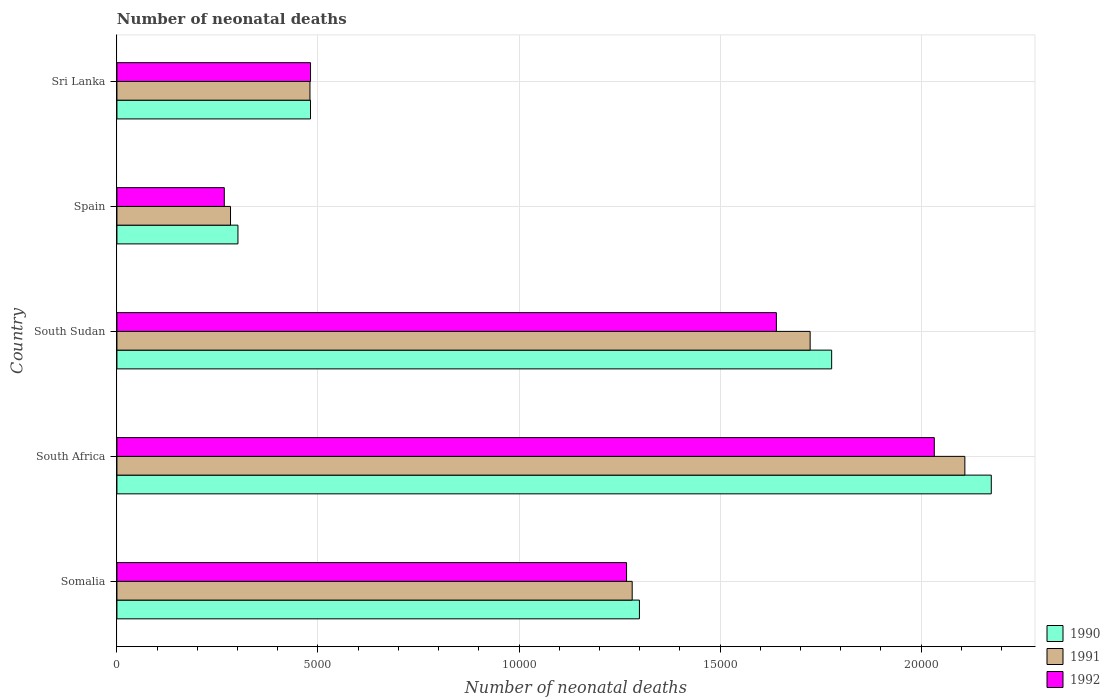How many different coloured bars are there?
Your answer should be very brief. 3. Are the number of bars per tick equal to the number of legend labels?
Provide a succinct answer. Yes. What is the label of the 2nd group of bars from the top?
Offer a terse response. Spain. What is the number of neonatal deaths in in 1991 in South Africa?
Ensure brevity in your answer.  2.11e+04. Across all countries, what is the maximum number of neonatal deaths in in 1992?
Provide a succinct answer. 2.03e+04. Across all countries, what is the minimum number of neonatal deaths in in 1991?
Ensure brevity in your answer.  2825. In which country was the number of neonatal deaths in in 1992 maximum?
Offer a very short reply. South Africa. What is the total number of neonatal deaths in in 1990 in the graph?
Your response must be concise. 6.03e+04. What is the difference between the number of neonatal deaths in in 1991 in Spain and that in Sri Lanka?
Your answer should be compact. -1976. What is the difference between the number of neonatal deaths in in 1990 in Sri Lanka and the number of neonatal deaths in in 1991 in South Sudan?
Ensure brevity in your answer.  -1.24e+04. What is the average number of neonatal deaths in in 1991 per country?
Keep it short and to the point. 1.18e+04. What is the difference between the number of neonatal deaths in in 1990 and number of neonatal deaths in in 1992 in Somalia?
Provide a short and direct response. 320. In how many countries, is the number of neonatal deaths in in 1991 greater than 4000 ?
Offer a very short reply. 4. What is the ratio of the number of neonatal deaths in in 1990 in Somalia to that in South Africa?
Keep it short and to the point. 0.6. Is the difference between the number of neonatal deaths in in 1990 in Spain and Sri Lanka greater than the difference between the number of neonatal deaths in in 1992 in Spain and Sri Lanka?
Keep it short and to the point. Yes. What is the difference between the highest and the second highest number of neonatal deaths in in 1992?
Keep it short and to the point. 3928. What is the difference between the highest and the lowest number of neonatal deaths in in 1991?
Offer a very short reply. 1.83e+04. In how many countries, is the number of neonatal deaths in in 1991 greater than the average number of neonatal deaths in in 1991 taken over all countries?
Provide a short and direct response. 3. Is the sum of the number of neonatal deaths in in 1992 in South Africa and Spain greater than the maximum number of neonatal deaths in in 1991 across all countries?
Your answer should be compact. Yes. What does the 2nd bar from the top in Sri Lanka represents?
Provide a short and direct response. 1991. Is it the case that in every country, the sum of the number of neonatal deaths in in 1992 and number of neonatal deaths in in 1990 is greater than the number of neonatal deaths in in 1991?
Your answer should be very brief. Yes. How many bars are there?
Offer a very short reply. 15. How many countries are there in the graph?
Ensure brevity in your answer.  5. Are the values on the major ticks of X-axis written in scientific E-notation?
Your answer should be very brief. No. Does the graph contain any zero values?
Your response must be concise. No. Does the graph contain grids?
Provide a short and direct response. Yes. Where does the legend appear in the graph?
Your answer should be compact. Bottom right. How many legend labels are there?
Make the answer very short. 3. What is the title of the graph?
Offer a terse response. Number of neonatal deaths. What is the label or title of the X-axis?
Your answer should be compact. Number of neonatal deaths. What is the Number of neonatal deaths of 1990 in Somalia?
Keep it short and to the point. 1.30e+04. What is the Number of neonatal deaths in 1991 in Somalia?
Offer a terse response. 1.28e+04. What is the Number of neonatal deaths in 1992 in Somalia?
Provide a short and direct response. 1.27e+04. What is the Number of neonatal deaths of 1990 in South Africa?
Your answer should be very brief. 2.17e+04. What is the Number of neonatal deaths of 1991 in South Africa?
Provide a short and direct response. 2.11e+04. What is the Number of neonatal deaths of 1992 in South Africa?
Offer a very short reply. 2.03e+04. What is the Number of neonatal deaths in 1990 in South Sudan?
Give a very brief answer. 1.78e+04. What is the Number of neonatal deaths in 1991 in South Sudan?
Your answer should be compact. 1.72e+04. What is the Number of neonatal deaths in 1992 in South Sudan?
Ensure brevity in your answer.  1.64e+04. What is the Number of neonatal deaths of 1990 in Spain?
Your answer should be very brief. 3010. What is the Number of neonatal deaths in 1991 in Spain?
Make the answer very short. 2825. What is the Number of neonatal deaths in 1992 in Spain?
Provide a short and direct response. 2670. What is the Number of neonatal deaths of 1990 in Sri Lanka?
Give a very brief answer. 4814. What is the Number of neonatal deaths of 1991 in Sri Lanka?
Ensure brevity in your answer.  4801. What is the Number of neonatal deaths in 1992 in Sri Lanka?
Provide a succinct answer. 4815. Across all countries, what is the maximum Number of neonatal deaths in 1990?
Keep it short and to the point. 2.17e+04. Across all countries, what is the maximum Number of neonatal deaths of 1991?
Provide a short and direct response. 2.11e+04. Across all countries, what is the maximum Number of neonatal deaths of 1992?
Ensure brevity in your answer.  2.03e+04. Across all countries, what is the minimum Number of neonatal deaths of 1990?
Offer a terse response. 3010. Across all countries, what is the minimum Number of neonatal deaths of 1991?
Your answer should be compact. 2825. Across all countries, what is the minimum Number of neonatal deaths in 1992?
Offer a very short reply. 2670. What is the total Number of neonatal deaths of 1990 in the graph?
Keep it short and to the point. 6.03e+04. What is the total Number of neonatal deaths in 1991 in the graph?
Keep it short and to the point. 5.88e+04. What is the total Number of neonatal deaths of 1992 in the graph?
Provide a succinct answer. 5.69e+04. What is the difference between the Number of neonatal deaths of 1990 in Somalia and that in South Africa?
Offer a very short reply. -8751. What is the difference between the Number of neonatal deaths of 1991 in Somalia and that in South Africa?
Your response must be concise. -8274. What is the difference between the Number of neonatal deaths of 1992 in Somalia and that in South Africa?
Ensure brevity in your answer.  -7654. What is the difference between the Number of neonatal deaths of 1990 in Somalia and that in South Sudan?
Keep it short and to the point. -4781. What is the difference between the Number of neonatal deaths of 1991 in Somalia and that in South Sudan?
Ensure brevity in your answer.  -4426. What is the difference between the Number of neonatal deaths of 1992 in Somalia and that in South Sudan?
Offer a very short reply. -3726. What is the difference between the Number of neonatal deaths of 1990 in Somalia and that in Spain?
Provide a succinct answer. 9985. What is the difference between the Number of neonatal deaths in 1991 in Somalia and that in Spain?
Offer a terse response. 9990. What is the difference between the Number of neonatal deaths of 1992 in Somalia and that in Spain?
Offer a very short reply. 1.00e+04. What is the difference between the Number of neonatal deaths in 1990 in Somalia and that in Sri Lanka?
Offer a very short reply. 8181. What is the difference between the Number of neonatal deaths in 1991 in Somalia and that in Sri Lanka?
Keep it short and to the point. 8014. What is the difference between the Number of neonatal deaths in 1992 in Somalia and that in Sri Lanka?
Give a very brief answer. 7860. What is the difference between the Number of neonatal deaths of 1990 in South Africa and that in South Sudan?
Your answer should be very brief. 3970. What is the difference between the Number of neonatal deaths in 1991 in South Africa and that in South Sudan?
Provide a short and direct response. 3848. What is the difference between the Number of neonatal deaths of 1992 in South Africa and that in South Sudan?
Provide a short and direct response. 3928. What is the difference between the Number of neonatal deaths in 1990 in South Africa and that in Spain?
Offer a terse response. 1.87e+04. What is the difference between the Number of neonatal deaths of 1991 in South Africa and that in Spain?
Your answer should be very brief. 1.83e+04. What is the difference between the Number of neonatal deaths of 1992 in South Africa and that in Spain?
Offer a very short reply. 1.77e+04. What is the difference between the Number of neonatal deaths of 1990 in South Africa and that in Sri Lanka?
Provide a short and direct response. 1.69e+04. What is the difference between the Number of neonatal deaths in 1991 in South Africa and that in Sri Lanka?
Your answer should be very brief. 1.63e+04. What is the difference between the Number of neonatal deaths in 1992 in South Africa and that in Sri Lanka?
Provide a succinct answer. 1.55e+04. What is the difference between the Number of neonatal deaths of 1990 in South Sudan and that in Spain?
Provide a short and direct response. 1.48e+04. What is the difference between the Number of neonatal deaths in 1991 in South Sudan and that in Spain?
Offer a terse response. 1.44e+04. What is the difference between the Number of neonatal deaths in 1992 in South Sudan and that in Spain?
Offer a terse response. 1.37e+04. What is the difference between the Number of neonatal deaths of 1990 in South Sudan and that in Sri Lanka?
Your response must be concise. 1.30e+04. What is the difference between the Number of neonatal deaths in 1991 in South Sudan and that in Sri Lanka?
Your answer should be very brief. 1.24e+04. What is the difference between the Number of neonatal deaths in 1992 in South Sudan and that in Sri Lanka?
Keep it short and to the point. 1.16e+04. What is the difference between the Number of neonatal deaths of 1990 in Spain and that in Sri Lanka?
Keep it short and to the point. -1804. What is the difference between the Number of neonatal deaths of 1991 in Spain and that in Sri Lanka?
Ensure brevity in your answer.  -1976. What is the difference between the Number of neonatal deaths of 1992 in Spain and that in Sri Lanka?
Offer a very short reply. -2145. What is the difference between the Number of neonatal deaths of 1990 in Somalia and the Number of neonatal deaths of 1991 in South Africa?
Your response must be concise. -8094. What is the difference between the Number of neonatal deaths of 1990 in Somalia and the Number of neonatal deaths of 1992 in South Africa?
Give a very brief answer. -7334. What is the difference between the Number of neonatal deaths of 1991 in Somalia and the Number of neonatal deaths of 1992 in South Africa?
Your answer should be compact. -7514. What is the difference between the Number of neonatal deaths of 1990 in Somalia and the Number of neonatal deaths of 1991 in South Sudan?
Your answer should be compact. -4246. What is the difference between the Number of neonatal deaths in 1990 in Somalia and the Number of neonatal deaths in 1992 in South Sudan?
Offer a very short reply. -3406. What is the difference between the Number of neonatal deaths in 1991 in Somalia and the Number of neonatal deaths in 1992 in South Sudan?
Provide a short and direct response. -3586. What is the difference between the Number of neonatal deaths in 1990 in Somalia and the Number of neonatal deaths in 1991 in Spain?
Give a very brief answer. 1.02e+04. What is the difference between the Number of neonatal deaths in 1990 in Somalia and the Number of neonatal deaths in 1992 in Spain?
Offer a terse response. 1.03e+04. What is the difference between the Number of neonatal deaths in 1991 in Somalia and the Number of neonatal deaths in 1992 in Spain?
Your answer should be very brief. 1.01e+04. What is the difference between the Number of neonatal deaths in 1990 in Somalia and the Number of neonatal deaths in 1991 in Sri Lanka?
Your answer should be compact. 8194. What is the difference between the Number of neonatal deaths in 1990 in Somalia and the Number of neonatal deaths in 1992 in Sri Lanka?
Provide a succinct answer. 8180. What is the difference between the Number of neonatal deaths of 1991 in Somalia and the Number of neonatal deaths of 1992 in Sri Lanka?
Your response must be concise. 8000. What is the difference between the Number of neonatal deaths in 1990 in South Africa and the Number of neonatal deaths in 1991 in South Sudan?
Your answer should be compact. 4505. What is the difference between the Number of neonatal deaths of 1990 in South Africa and the Number of neonatal deaths of 1992 in South Sudan?
Ensure brevity in your answer.  5345. What is the difference between the Number of neonatal deaths in 1991 in South Africa and the Number of neonatal deaths in 1992 in South Sudan?
Offer a terse response. 4688. What is the difference between the Number of neonatal deaths in 1990 in South Africa and the Number of neonatal deaths in 1991 in Spain?
Make the answer very short. 1.89e+04. What is the difference between the Number of neonatal deaths of 1990 in South Africa and the Number of neonatal deaths of 1992 in Spain?
Keep it short and to the point. 1.91e+04. What is the difference between the Number of neonatal deaths in 1991 in South Africa and the Number of neonatal deaths in 1992 in Spain?
Your response must be concise. 1.84e+04. What is the difference between the Number of neonatal deaths of 1990 in South Africa and the Number of neonatal deaths of 1991 in Sri Lanka?
Provide a short and direct response. 1.69e+04. What is the difference between the Number of neonatal deaths of 1990 in South Africa and the Number of neonatal deaths of 1992 in Sri Lanka?
Your answer should be compact. 1.69e+04. What is the difference between the Number of neonatal deaths in 1991 in South Africa and the Number of neonatal deaths in 1992 in Sri Lanka?
Your answer should be compact. 1.63e+04. What is the difference between the Number of neonatal deaths in 1990 in South Sudan and the Number of neonatal deaths in 1991 in Spain?
Ensure brevity in your answer.  1.50e+04. What is the difference between the Number of neonatal deaths in 1990 in South Sudan and the Number of neonatal deaths in 1992 in Spain?
Offer a very short reply. 1.51e+04. What is the difference between the Number of neonatal deaths of 1991 in South Sudan and the Number of neonatal deaths of 1992 in Spain?
Keep it short and to the point. 1.46e+04. What is the difference between the Number of neonatal deaths of 1990 in South Sudan and the Number of neonatal deaths of 1991 in Sri Lanka?
Make the answer very short. 1.30e+04. What is the difference between the Number of neonatal deaths in 1990 in South Sudan and the Number of neonatal deaths in 1992 in Sri Lanka?
Offer a very short reply. 1.30e+04. What is the difference between the Number of neonatal deaths of 1991 in South Sudan and the Number of neonatal deaths of 1992 in Sri Lanka?
Your response must be concise. 1.24e+04. What is the difference between the Number of neonatal deaths in 1990 in Spain and the Number of neonatal deaths in 1991 in Sri Lanka?
Keep it short and to the point. -1791. What is the difference between the Number of neonatal deaths of 1990 in Spain and the Number of neonatal deaths of 1992 in Sri Lanka?
Provide a succinct answer. -1805. What is the difference between the Number of neonatal deaths of 1991 in Spain and the Number of neonatal deaths of 1992 in Sri Lanka?
Offer a very short reply. -1990. What is the average Number of neonatal deaths of 1990 per country?
Make the answer very short. 1.21e+04. What is the average Number of neonatal deaths of 1991 per country?
Offer a very short reply. 1.18e+04. What is the average Number of neonatal deaths of 1992 per country?
Your answer should be compact. 1.14e+04. What is the difference between the Number of neonatal deaths of 1990 and Number of neonatal deaths of 1991 in Somalia?
Make the answer very short. 180. What is the difference between the Number of neonatal deaths of 1990 and Number of neonatal deaths of 1992 in Somalia?
Offer a very short reply. 320. What is the difference between the Number of neonatal deaths of 1991 and Number of neonatal deaths of 1992 in Somalia?
Offer a very short reply. 140. What is the difference between the Number of neonatal deaths in 1990 and Number of neonatal deaths in 1991 in South Africa?
Your answer should be very brief. 657. What is the difference between the Number of neonatal deaths of 1990 and Number of neonatal deaths of 1992 in South Africa?
Ensure brevity in your answer.  1417. What is the difference between the Number of neonatal deaths in 1991 and Number of neonatal deaths in 1992 in South Africa?
Provide a short and direct response. 760. What is the difference between the Number of neonatal deaths of 1990 and Number of neonatal deaths of 1991 in South Sudan?
Your response must be concise. 535. What is the difference between the Number of neonatal deaths of 1990 and Number of neonatal deaths of 1992 in South Sudan?
Provide a succinct answer. 1375. What is the difference between the Number of neonatal deaths of 1991 and Number of neonatal deaths of 1992 in South Sudan?
Give a very brief answer. 840. What is the difference between the Number of neonatal deaths of 1990 and Number of neonatal deaths of 1991 in Spain?
Ensure brevity in your answer.  185. What is the difference between the Number of neonatal deaths in 1990 and Number of neonatal deaths in 1992 in Spain?
Your answer should be very brief. 340. What is the difference between the Number of neonatal deaths in 1991 and Number of neonatal deaths in 1992 in Spain?
Keep it short and to the point. 155. What is the difference between the Number of neonatal deaths of 1990 and Number of neonatal deaths of 1992 in Sri Lanka?
Keep it short and to the point. -1. What is the difference between the Number of neonatal deaths of 1991 and Number of neonatal deaths of 1992 in Sri Lanka?
Keep it short and to the point. -14. What is the ratio of the Number of neonatal deaths of 1990 in Somalia to that in South Africa?
Provide a succinct answer. 0.6. What is the ratio of the Number of neonatal deaths in 1991 in Somalia to that in South Africa?
Keep it short and to the point. 0.61. What is the ratio of the Number of neonatal deaths in 1992 in Somalia to that in South Africa?
Provide a succinct answer. 0.62. What is the ratio of the Number of neonatal deaths in 1990 in Somalia to that in South Sudan?
Give a very brief answer. 0.73. What is the ratio of the Number of neonatal deaths in 1991 in Somalia to that in South Sudan?
Your answer should be compact. 0.74. What is the ratio of the Number of neonatal deaths of 1992 in Somalia to that in South Sudan?
Ensure brevity in your answer.  0.77. What is the ratio of the Number of neonatal deaths of 1990 in Somalia to that in Spain?
Your answer should be compact. 4.32. What is the ratio of the Number of neonatal deaths of 1991 in Somalia to that in Spain?
Offer a terse response. 4.54. What is the ratio of the Number of neonatal deaths in 1992 in Somalia to that in Spain?
Make the answer very short. 4.75. What is the ratio of the Number of neonatal deaths in 1990 in Somalia to that in Sri Lanka?
Your answer should be compact. 2.7. What is the ratio of the Number of neonatal deaths in 1991 in Somalia to that in Sri Lanka?
Keep it short and to the point. 2.67. What is the ratio of the Number of neonatal deaths of 1992 in Somalia to that in Sri Lanka?
Offer a very short reply. 2.63. What is the ratio of the Number of neonatal deaths in 1990 in South Africa to that in South Sudan?
Offer a very short reply. 1.22. What is the ratio of the Number of neonatal deaths in 1991 in South Africa to that in South Sudan?
Your answer should be compact. 1.22. What is the ratio of the Number of neonatal deaths in 1992 in South Africa to that in South Sudan?
Your response must be concise. 1.24. What is the ratio of the Number of neonatal deaths in 1990 in South Africa to that in Spain?
Ensure brevity in your answer.  7.22. What is the ratio of the Number of neonatal deaths of 1991 in South Africa to that in Spain?
Your answer should be compact. 7.47. What is the ratio of the Number of neonatal deaths of 1992 in South Africa to that in Spain?
Offer a very short reply. 7.61. What is the ratio of the Number of neonatal deaths in 1990 in South Africa to that in Sri Lanka?
Make the answer very short. 4.52. What is the ratio of the Number of neonatal deaths of 1991 in South Africa to that in Sri Lanka?
Make the answer very short. 4.39. What is the ratio of the Number of neonatal deaths in 1992 in South Africa to that in Sri Lanka?
Your answer should be very brief. 4.22. What is the ratio of the Number of neonatal deaths in 1990 in South Sudan to that in Spain?
Give a very brief answer. 5.91. What is the ratio of the Number of neonatal deaths of 1991 in South Sudan to that in Spain?
Offer a terse response. 6.1. What is the ratio of the Number of neonatal deaths in 1992 in South Sudan to that in Spain?
Make the answer very short. 6.14. What is the ratio of the Number of neonatal deaths in 1990 in South Sudan to that in Sri Lanka?
Your answer should be compact. 3.69. What is the ratio of the Number of neonatal deaths in 1991 in South Sudan to that in Sri Lanka?
Provide a succinct answer. 3.59. What is the ratio of the Number of neonatal deaths of 1992 in South Sudan to that in Sri Lanka?
Keep it short and to the point. 3.41. What is the ratio of the Number of neonatal deaths in 1990 in Spain to that in Sri Lanka?
Provide a short and direct response. 0.63. What is the ratio of the Number of neonatal deaths of 1991 in Spain to that in Sri Lanka?
Provide a short and direct response. 0.59. What is the ratio of the Number of neonatal deaths in 1992 in Spain to that in Sri Lanka?
Offer a terse response. 0.55. What is the difference between the highest and the second highest Number of neonatal deaths of 1990?
Your response must be concise. 3970. What is the difference between the highest and the second highest Number of neonatal deaths of 1991?
Make the answer very short. 3848. What is the difference between the highest and the second highest Number of neonatal deaths of 1992?
Give a very brief answer. 3928. What is the difference between the highest and the lowest Number of neonatal deaths of 1990?
Keep it short and to the point. 1.87e+04. What is the difference between the highest and the lowest Number of neonatal deaths in 1991?
Offer a very short reply. 1.83e+04. What is the difference between the highest and the lowest Number of neonatal deaths of 1992?
Provide a succinct answer. 1.77e+04. 